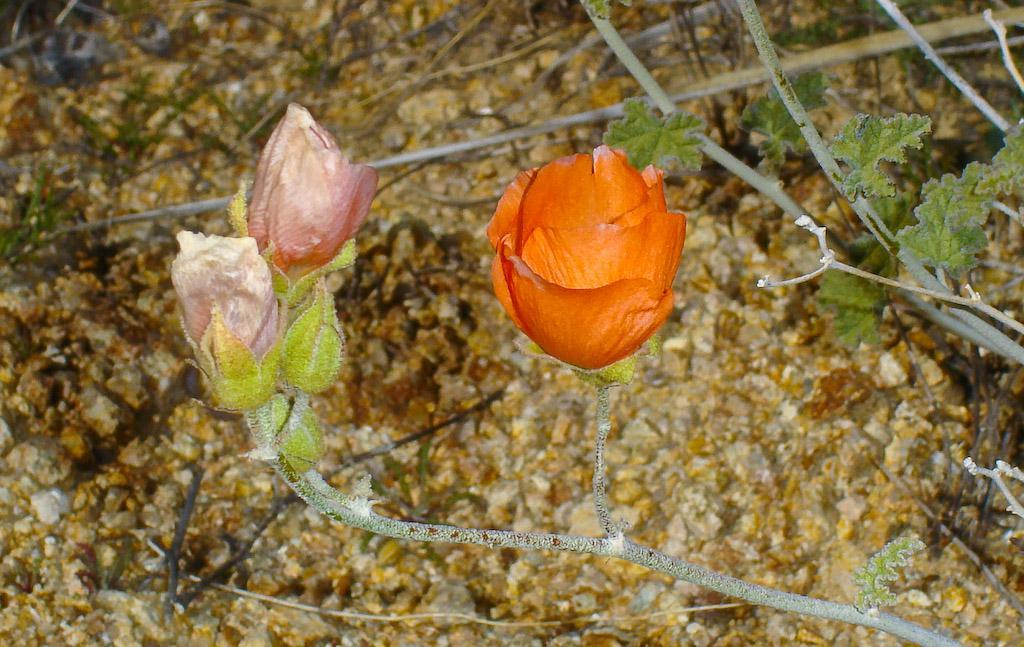What type of living organisms can be seen in the image? Flowers and plants can be seen in the image. Can you describe the plants in the image? The plants in the image are flowers. What is the rate of the thunder in the image? There is no thunder present in the image, so it is not possible to determine its rate. 